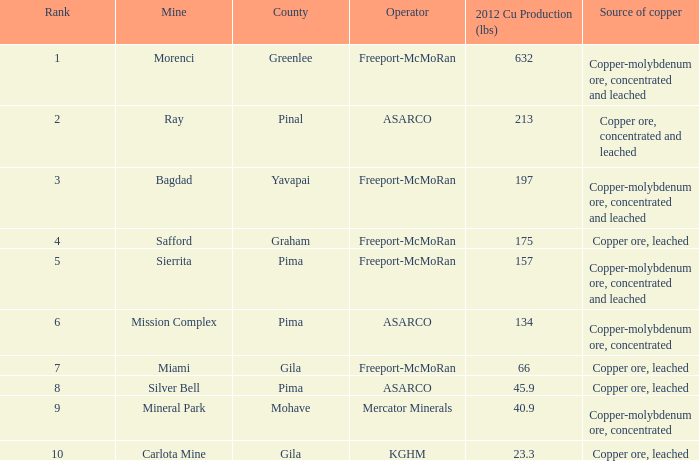Help me parse the entirety of this table. {'header': ['Rank', 'Mine', 'County', 'Operator', '2012 Cu Production (lbs)', 'Source of copper'], 'rows': [['1', 'Morenci', 'Greenlee', 'Freeport-McMoRan', '632', 'Copper-molybdenum ore, concentrated and leached'], ['2', 'Ray', 'Pinal', 'ASARCO', '213', 'Copper ore, concentrated and leached'], ['3', 'Bagdad', 'Yavapai', 'Freeport-McMoRan', '197', 'Copper-molybdenum ore, concentrated and leached'], ['4', 'Safford', 'Graham', 'Freeport-McMoRan', '175', 'Copper ore, leached'], ['5', 'Sierrita', 'Pima', 'Freeport-McMoRan', '157', 'Copper-molybdenum ore, concentrated and leached'], ['6', 'Mission Complex', 'Pima', 'ASARCO', '134', 'Copper-molybdenum ore, concentrated'], ['7', 'Miami', 'Gila', 'Freeport-McMoRan', '66', 'Copper ore, leached'], ['8', 'Silver Bell', 'Pima', 'ASARCO', '45.9', 'Copper ore, leached'], ['9', 'Mineral Park', 'Mohave', 'Mercator Minerals', '40.9', 'Copper-molybdenum ore, concentrated'], ['10', 'Carlota Mine', 'Gila', 'KGHM', '23.3', 'Copper ore, leached']]} What's the lowest ranking source of copper, copper ore, concentrated and leached? 2.0. 